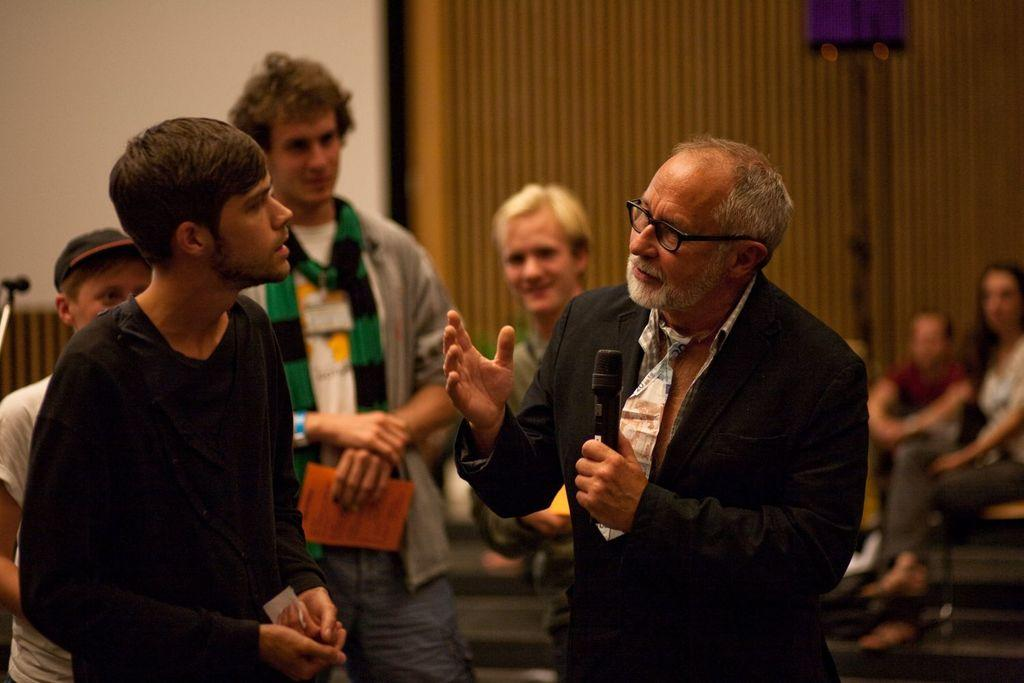How many people are in the image? There is a group of people in the image. What is one person in the group holding? One person is holding a microphone. What can be seen in the background of the image? There is a wall in the background of the image. What is the color of the wall? The wall is white in color. Can you see any goldfish swimming near the wall in the image? There are no goldfish present in the image; it features a group of people and a white wall in the background. 